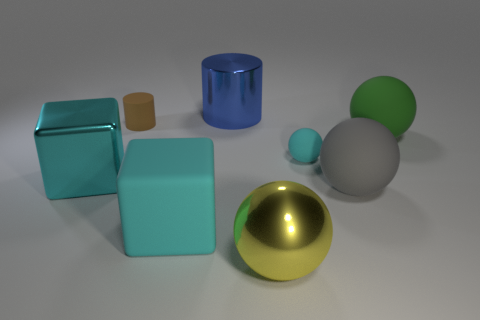There is a cylinder that is the same size as the green thing; what material is it?
Keep it short and to the point. Metal. There is a cyan metal block; is it the same size as the sphere behind the cyan matte sphere?
Ensure brevity in your answer.  Yes. What is the cube left of the matte cylinder made of?
Your answer should be very brief. Metal. Is the number of rubber spheres behind the small cyan matte thing the same as the number of green balls?
Ensure brevity in your answer.  Yes. Is the size of the yellow sphere the same as the cyan rubber sphere?
Your answer should be compact. No. Are there any large gray rubber spheres that are left of the object that is to the right of the big gray matte object in front of the brown matte object?
Offer a very short reply. Yes. There is a yellow thing that is the same shape as the big green rubber thing; what material is it?
Provide a succinct answer. Metal. How many cyan matte objects are in front of the cyan matte object to the left of the small matte sphere?
Your response must be concise. 0. What is the size of the matte thing behind the big rubber ball that is behind the tiny object that is in front of the tiny brown cylinder?
Ensure brevity in your answer.  Small. What is the color of the large ball in front of the large rubber ball in front of the big green sphere?
Provide a succinct answer. Yellow. 